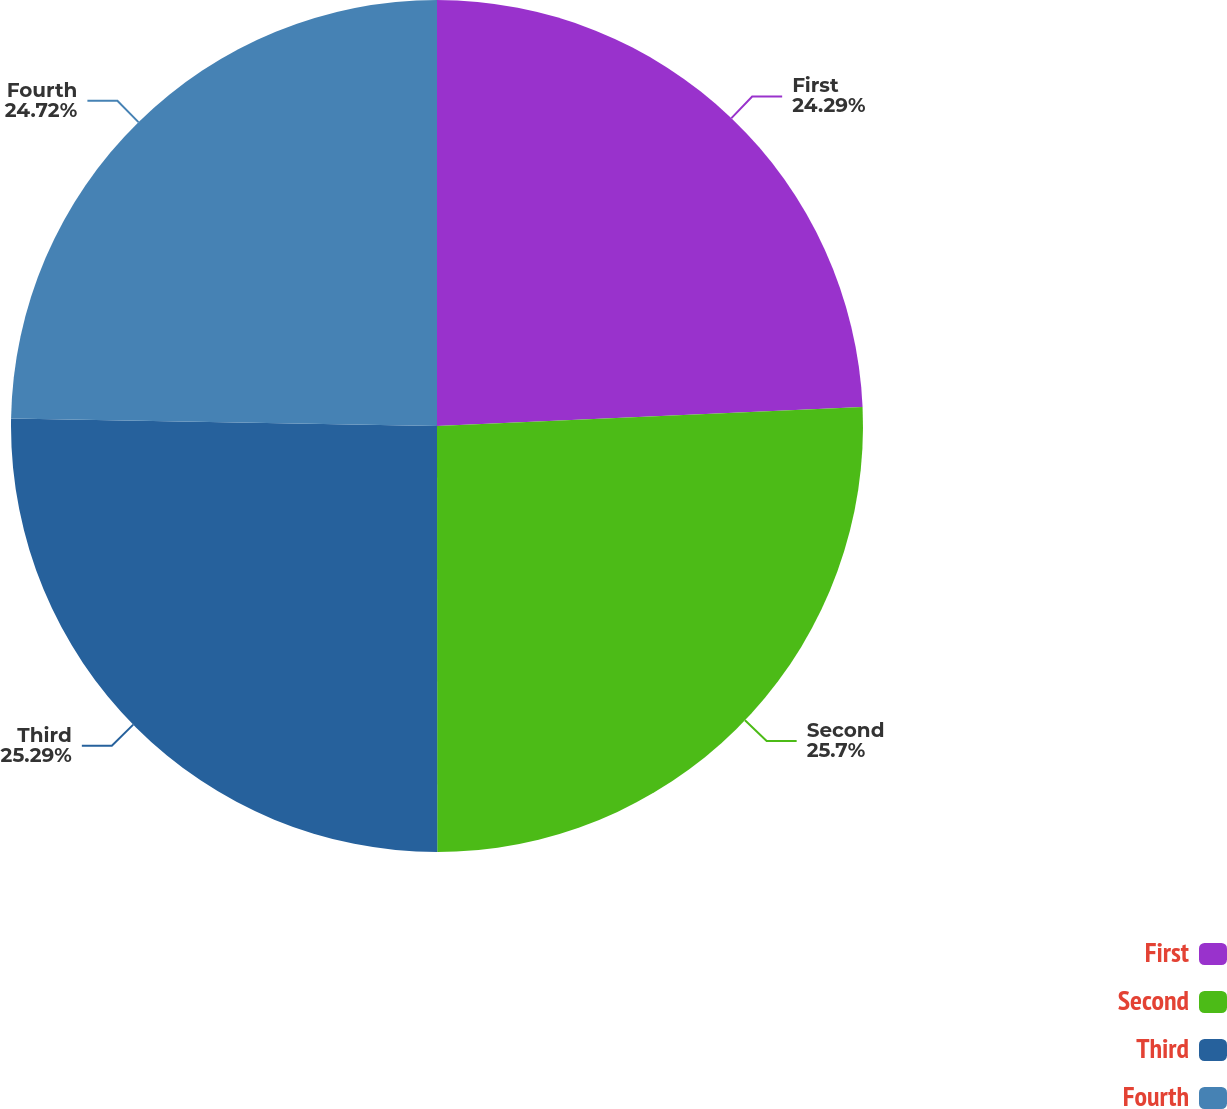<chart> <loc_0><loc_0><loc_500><loc_500><pie_chart><fcel>First<fcel>Second<fcel>Third<fcel>Fourth<nl><fcel>24.29%<fcel>25.7%<fcel>25.29%<fcel>24.72%<nl></chart> 